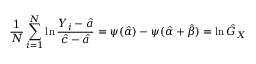Convert formula to latex. <formula><loc_0><loc_0><loc_500><loc_500>{ \frac { 1 } { N } } \sum _ { i = 1 } ^ { N } \ln { \frac { Y _ { i } - { \hat { a } } } { { \hat { c } } - { \hat { a } } } } = \psi ( { \hat { \alpha } } ) - \psi ( { \hat { \alpha } } + { \hat { \beta } } ) = \ln { \hat { G } } _ { X }</formula> 